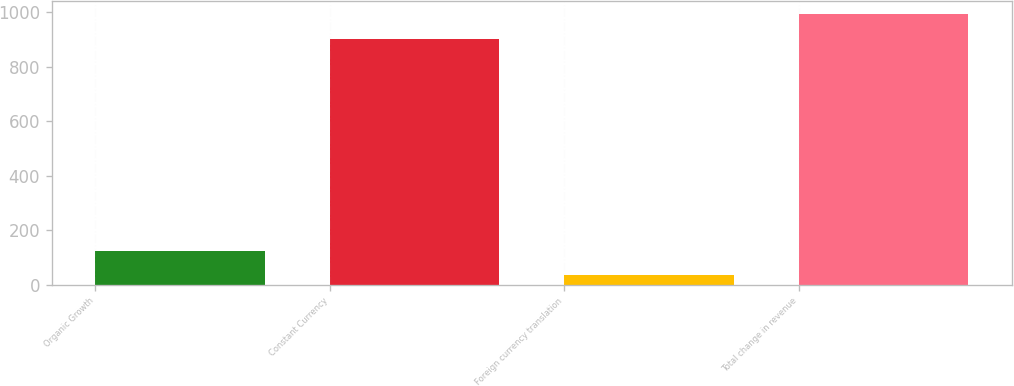Convert chart to OTSL. <chart><loc_0><loc_0><loc_500><loc_500><bar_chart><fcel>Organic Growth<fcel>Constant Currency<fcel>Foreign currency translation<fcel>Total change in revenue<nl><fcel>124.2<fcel>902<fcel>34<fcel>992.2<nl></chart> 